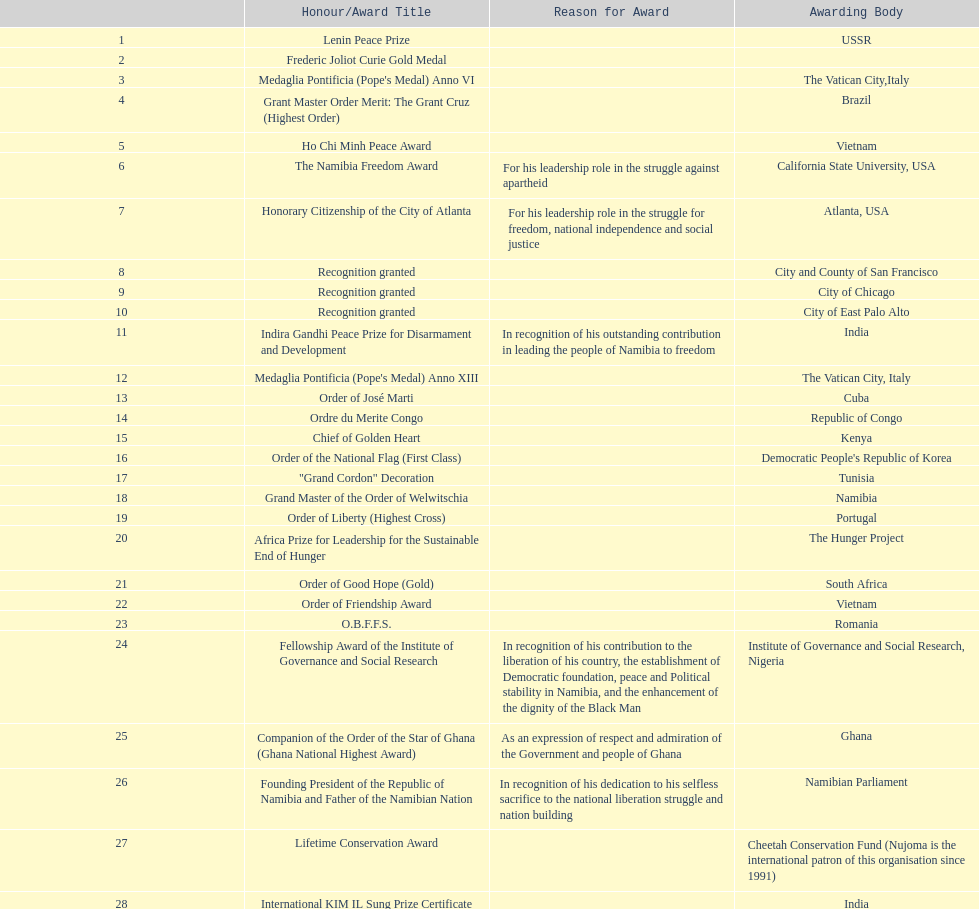According to this chart, how many total honors/award titles were mentioned? 29. 